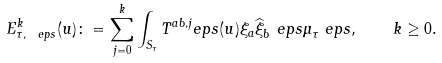<formula> <loc_0><loc_0><loc_500><loc_500>E ^ { k } _ { \tau , \ e p s } ( u ) \colon = \sum _ { j = 0 } ^ { k } \int _ { S _ { \tau } } T ^ { a b , j } _ { \ } e p s ( u ) \xi _ { a } \widehat { \xi } _ { b } ^ { \ } e p s \mu _ { \tau } ^ { \ } e p s , \quad k \geq 0 .</formula> 